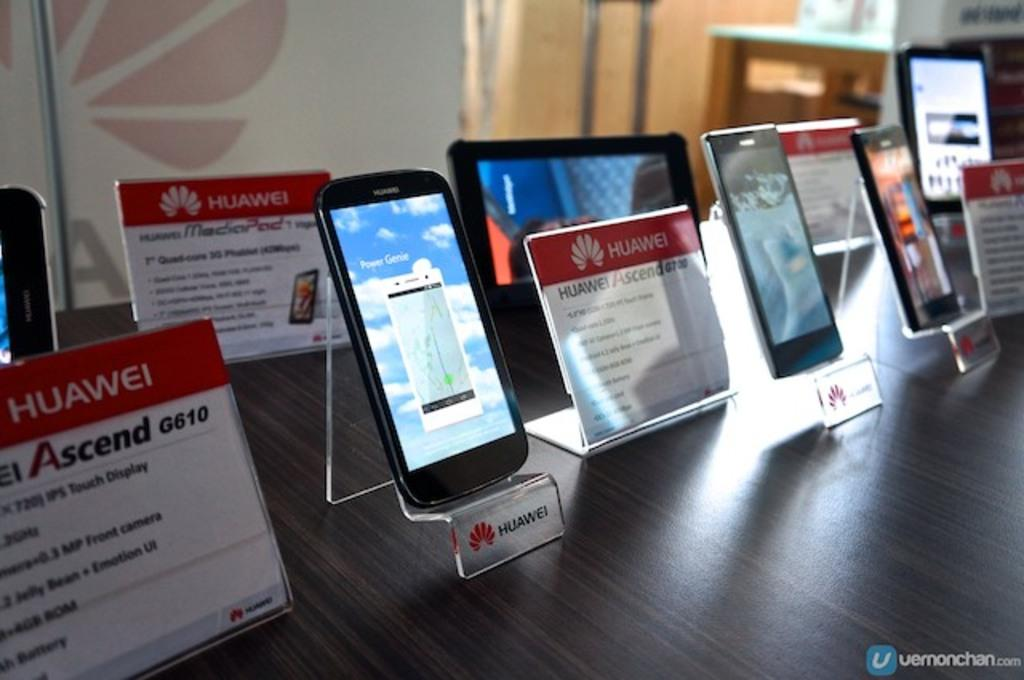What type of furniture is present in the image? There are tables in the image. What other objects can be seen in the image? There are mobiles and information boards in the image. What is the purpose of the banner in the image? The purpose of the banner in the image is not specified, but it might be used for advertising or conveying information. What is written on the information boards? Something is written on the information boards, but the specific content is not mentioned. Can you compare the size of the teeth on the mobiles in the image? There are no teeth present on the mobiles in the image. What type of performance is happening on the stage in the image? There is no stage present in the image. 